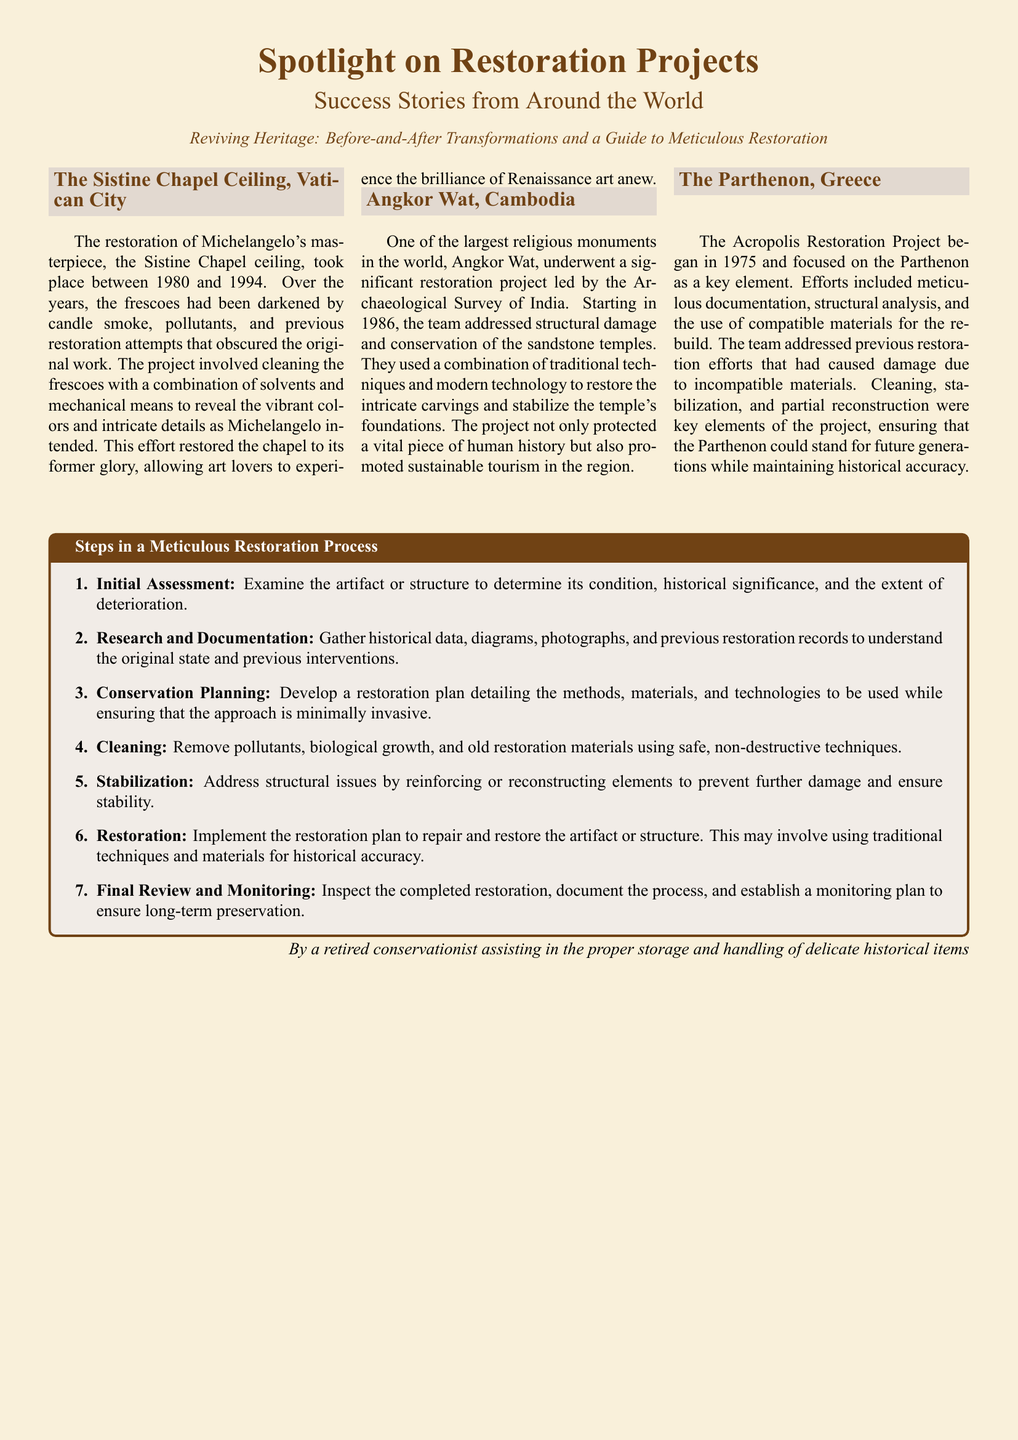What is the title of the document? The title of the document is prominently displayed at the top, highlighting the focus on restoration projects.
Answer: Spotlight on Restoration Projects When did the restoration of the Sistine Chapel Ceiling take place? The document specifies the period of restoration efforts for the Sistine Chapel Ceiling.
Answer: 1980 to 1994 Who led the restoration project of Angkor Wat? The document mentions the organization responsible for the restoration project of Angkor Wat.
Answer: Archaeological Survey of India What is the first step in the restoration process? The document outlines a specific sequence of steps, identifying the initial action taken in restoration.
Answer: Initial Assessment How many restoration projects are highlighted in the document? The document lists and describes multiple restoration projects, which could be counted to derive the total.
Answer: Three What issue did the Acropolis Restoration Project address? The document outlines specific challenges that were tackled during the restoration of the Acropolis.
Answer: Previous restoration damages What type of document is this? The overall formatting and presentation suggest a specific type of publication.
Answer: Newspaper layout 